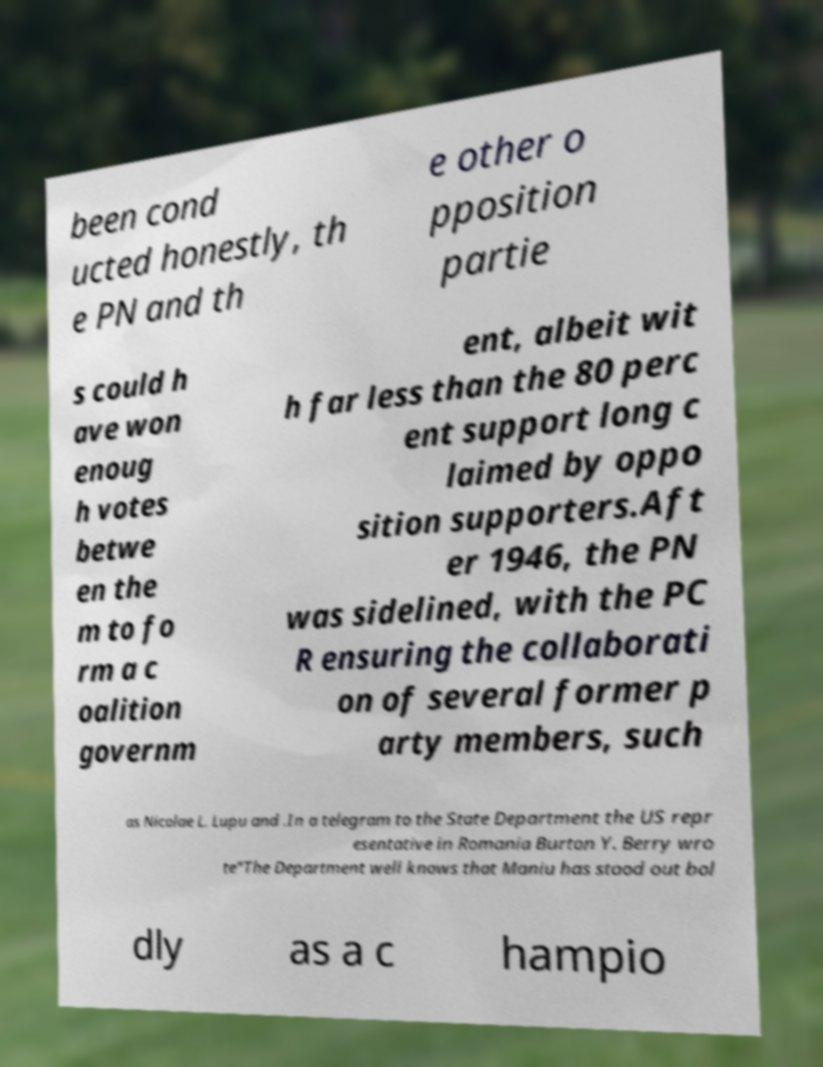What messages or text are displayed in this image? I need them in a readable, typed format. been cond ucted honestly, th e PN and th e other o pposition partie s could h ave won enoug h votes betwe en the m to fo rm a c oalition governm ent, albeit wit h far less than the 80 perc ent support long c laimed by oppo sition supporters.Aft er 1946, the PN was sidelined, with the PC R ensuring the collaborati on of several former p arty members, such as Nicolae L. Lupu and .In a telegram to the State Department the US repr esentative in Romania Burton Y. Berry wro te"The Department well knows that Maniu has stood out bol dly as a c hampio 